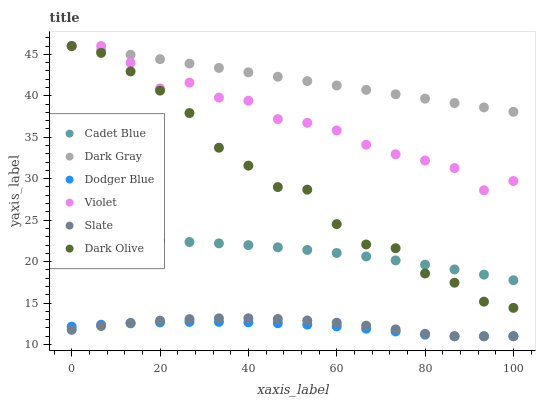Does Dodger Blue have the minimum area under the curve?
Answer yes or no. Yes. Does Dark Gray have the maximum area under the curve?
Answer yes or no. Yes. Does Slate have the minimum area under the curve?
Answer yes or no. No. Does Slate have the maximum area under the curve?
Answer yes or no. No. Is Dark Gray the smoothest?
Answer yes or no. Yes. Is Dark Olive the roughest?
Answer yes or no. Yes. Is Slate the smoothest?
Answer yes or no. No. Is Slate the roughest?
Answer yes or no. No. Does Slate have the lowest value?
Answer yes or no. Yes. Does Dark Olive have the lowest value?
Answer yes or no. No. Does Violet have the highest value?
Answer yes or no. Yes. Does Slate have the highest value?
Answer yes or no. No. Is Slate less than Dark Gray?
Answer yes or no. Yes. Is Violet greater than Slate?
Answer yes or no. Yes. Does Dark Olive intersect Violet?
Answer yes or no. Yes. Is Dark Olive less than Violet?
Answer yes or no. No. Is Dark Olive greater than Violet?
Answer yes or no. No. Does Slate intersect Dark Gray?
Answer yes or no. No. 